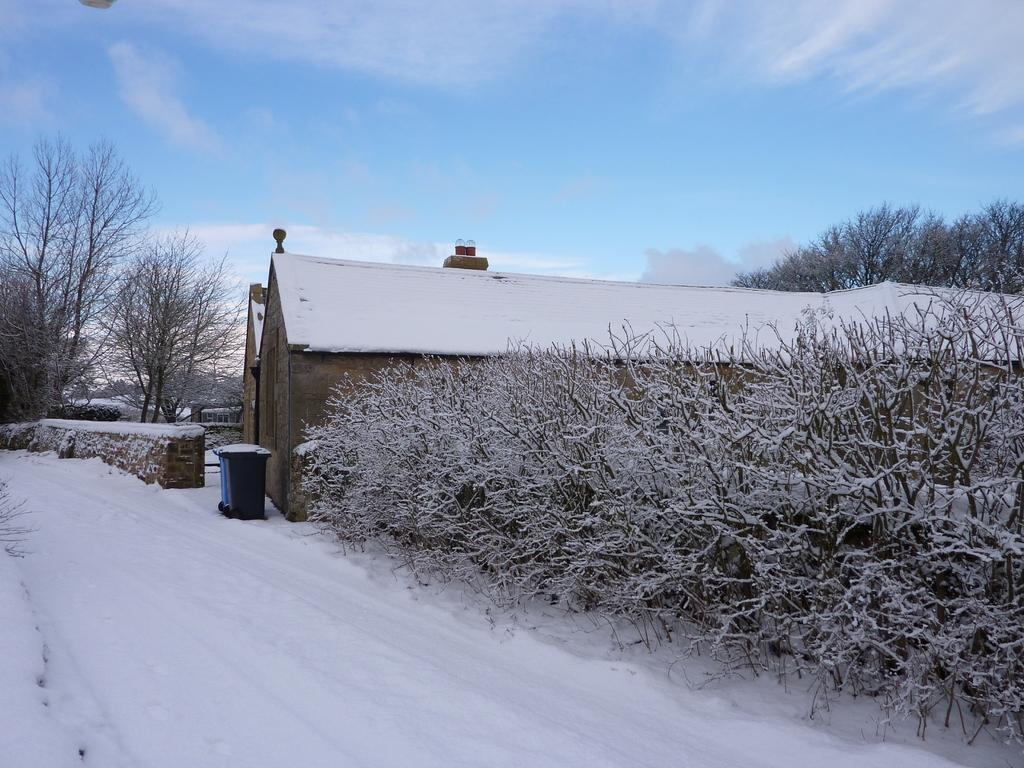Could you give a brief overview of what you see in this image? In the image there are two houses and around the houses there are many trees covered with snow and the path in front of the houses also filled with dense ice. 